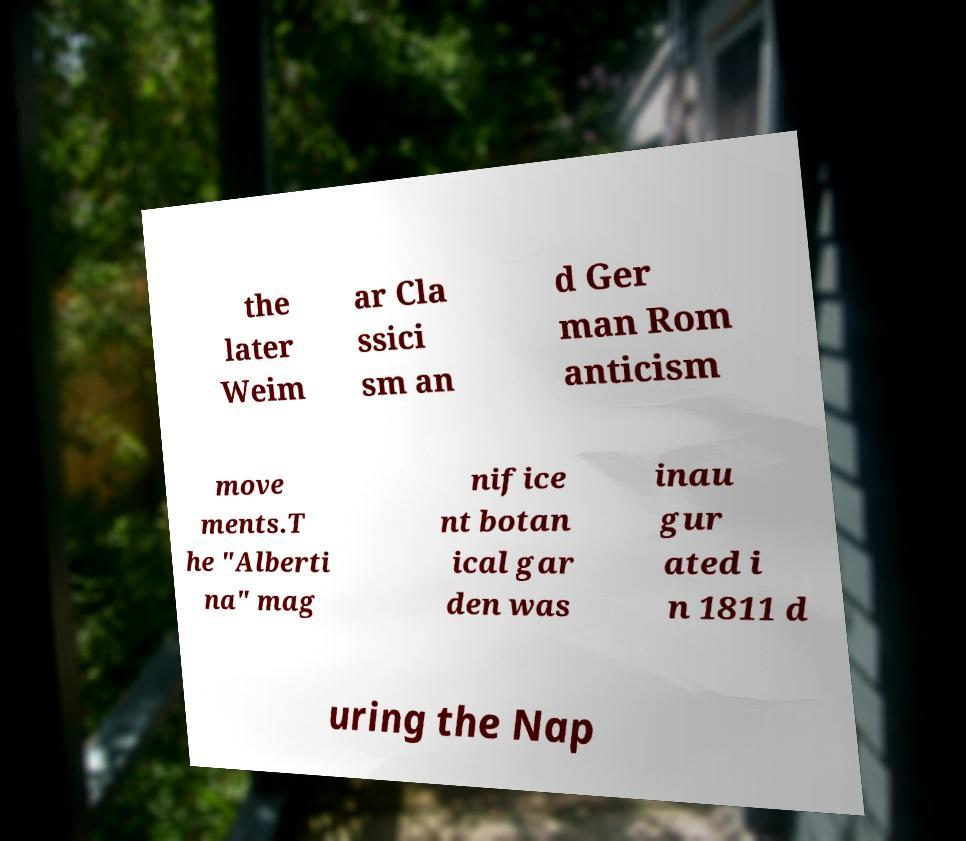For documentation purposes, I need the text within this image transcribed. Could you provide that? the later Weim ar Cla ssici sm an d Ger man Rom anticism move ments.T he "Alberti na" mag nifice nt botan ical gar den was inau gur ated i n 1811 d uring the Nap 